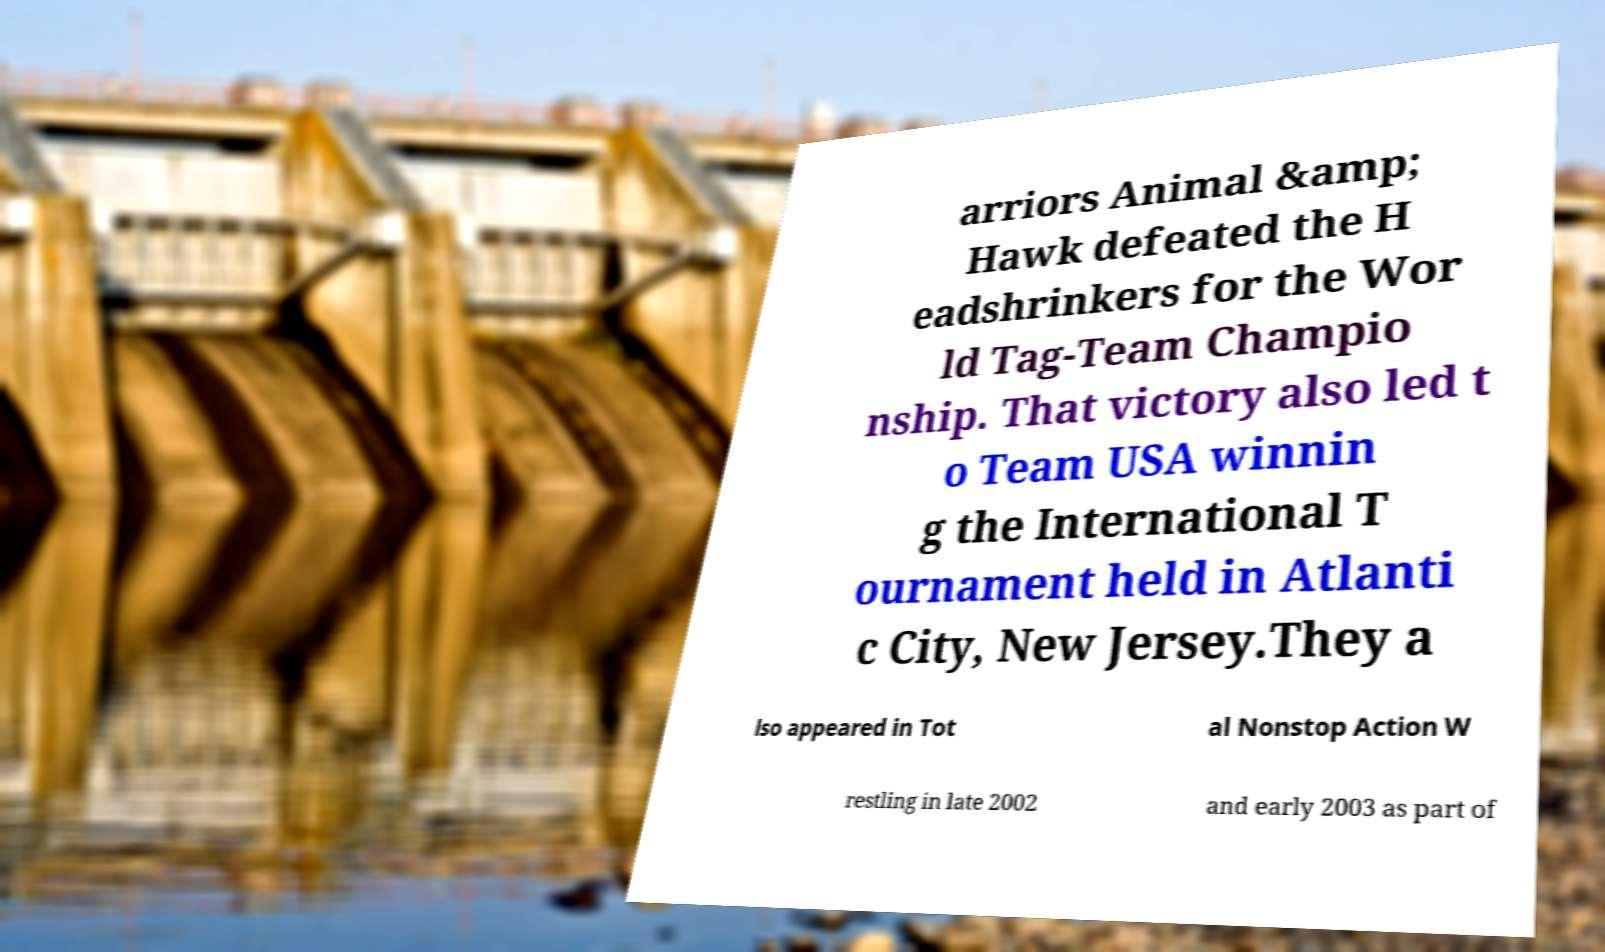Could you assist in decoding the text presented in this image and type it out clearly? arriors Animal &amp; Hawk defeated the H eadshrinkers for the Wor ld Tag-Team Champio nship. That victory also led t o Team USA winnin g the International T ournament held in Atlanti c City, New Jersey.They a lso appeared in Tot al Nonstop Action W restling in late 2002 and early 2003 as part of 